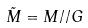<formula> <loc_0><loc_0><loc_500><loc_500>\tilde { M } = M / / G</formula> 